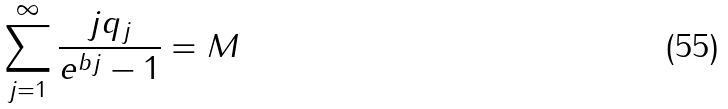<formula> <loc_0><loc_0><loc_500><loc_500>\sum _ { j = 1 } ^ { \infty } \frac { j q _ { j } } { e ^ { b j } - 1 } = M</formula> 